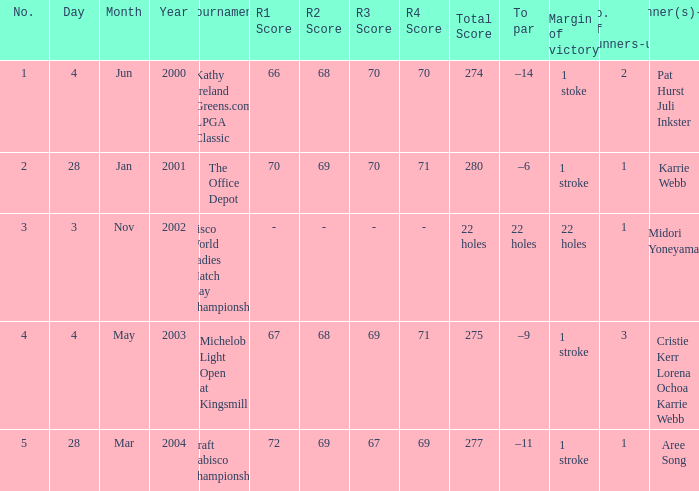What date were the runner ups pat hurst juli inkster? Jun 4, 2000. 